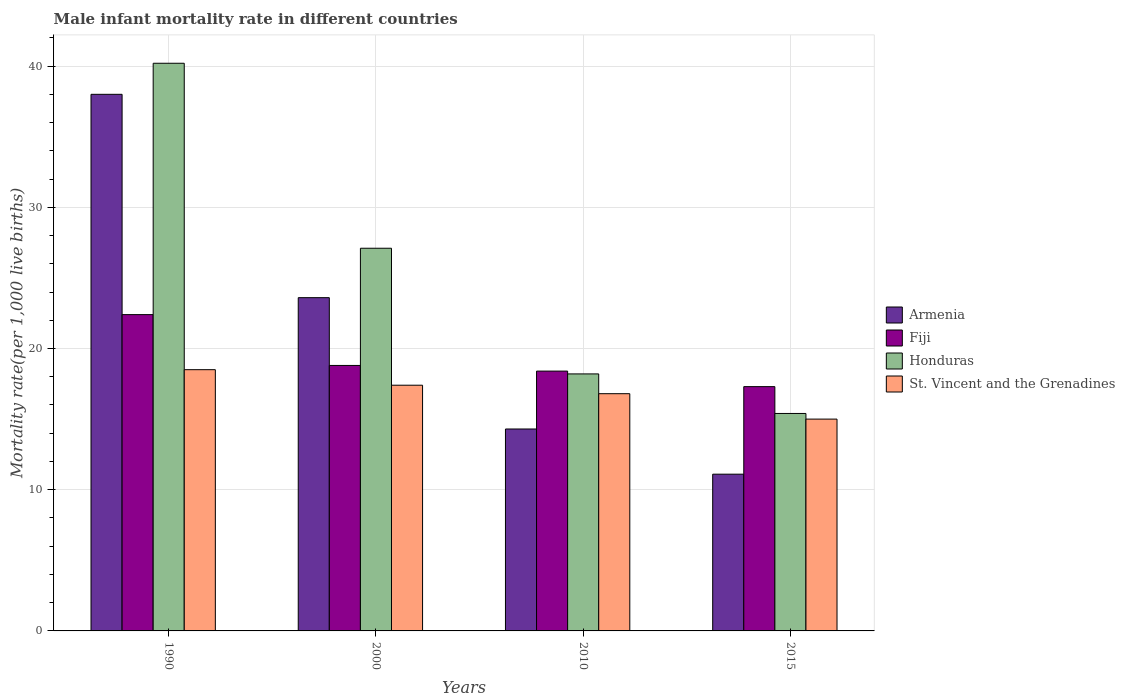Are the number of bars per tick equal to the number of legend labels?
Keep it short and to the point. Yes. How many bars are there on the 3rd tick from the left?
Your response must be concise. 4. What is the label of the 1st group of bars from the left?
Provide a succinct answer. 1990. In how many cases, is the number of bars for a given year not equal to the number of legend labels?
Provide a short and direct response. 0. What is the male infant mortality rate in Armenia in 1990?
Ensure brevity in your answer.  38. Across all years, what is the maximum male infant mortality rate in Honduras?
Your answer should be very brief. 40.2. In which year was the male infant mortality rate in Armenia minimum?
Your answer should be very brief. 2015. What is the total male infant mortality rate in Fiji in the graph?
Your response must be concise. 76.9. What is the difference between the male infant mortality rate in Fiji in 1990 and that in 2000?
Offer a terse response. 3.6. What is the difference between the male infant mortality rate in Fiji in 2015 and the male infant mortality rate in Armenia in 1990?
Provide a short and direct response. -20.7. What is the average male infant mortality rate in St. Vincent and the Grenadines per year?
Your response must be concise. 16.93. In how many years, is the male infant mortality rate in Honduras greater than 26?
Provide a short and direct response. 2. What is the ratio of the male infant mortality rate in St. Vincent and the Grenadines in 1990 to that in 2010?
Your response must be concise. 1.1. Is the male infant mortality rate in Fiji in 1990 less than that in 2015?
Offer a terse response. No. Is the difference between the male infant mortality rate in St. Vincent and the Grenadines in 2000 and 2010 greater than the difference between the male infant mortality rate in Armenia in 2000 and 2010?
Offer a terse response. No. What is the difference between the highest and the second highest male infant mortality rate in Armenia?
Your answer should be very brief. 14.4. What is the difference between the highest and the lowest male infant mortality rate in Honduras?
Offer a terse response. 24.8. In how many years, is the male infant mortality rate in St. Vincent and the Grenadines greater than the average male infant mortality rate in St. Vincent and the Grenadines taken over all years?
Keep it short and to the point. 2. Is the sum of the male infant mortality rate in St. Vincent and the Grenadines in 2010 and 2015 greater than the maximum male infant mortality rate in Honduras across all years?
Give a very brief answer. No. Is it the case that in every year, the sum of the male infant mortality rate in Fiji and male infant mortality rate in St. Vincent and the Grenadines is greater than the sum of male infant mortality rate in Armenia and male infant mortality rate in Honduras?
Offer a terse response. No. What does the 3rd bar from the left in 2010 represents?
Make the answer very short. Honduras. What does the 2nd bar from the right in 2015 represents?
Your response must be concise. Honduras. Are all the bars in the graph horizontal?
Give a very brief answer. No. What is the difference between two consecutive major ticks on the Y-axis?
Your answer should be very brief. 10. Are the values on the major ticks of Y-axis written in scientific E-notation?
Ensure brevity in your answer.  No. Does the graph contain any zero values?
Offer a very short reply. No. How many legend labels are there?
Your response must be concise. 4. What is the title of the graph?
Give a very brief answer. Male infant mortality rate in different countries. Does "Ireland" appear as one of the legend labels in the graph?
Your answer should be very brief. No. What is the label or title of the Y-axis?
Your response must be concise. Mortality rate(per 1,0 live births). What is the Mortality rate(per 1,000 live births) in Armenia in 1990?
Ensure brevity in your answer.  38. What is the Mortality rate(per 1,000 live births) in Fiji in 1990?
Keep it short and to the point. 22.4. What is the Mortality rate(per 1,000 live births) in Honduras in 1990?
Give a very brief answer. 40.2. What is the Mortality rate(per 1,000 live births) of St. Vincent and the Grenadines in 1990?
Your response must be concise. 18.5. What is the Mortality rate(per 1,000 live births) in Armenia in 2000?
Provide a short and direct response. 23.6. What is the Mortality rate(per 1,000 live births) in Fiji in 2000?
Your answer should be compact. 18.8. What is the Mortality rate(per 1,000 live births) in Honduras in 2000?
Make the answer very short. 27.1. What is the Mortality rate(per 1,000 live births) in Armenia in 2010?
Provide a succinct answer. 14.3. What is the Mortality rate(per 1,000 live births) of Honduras in 2015?
Your response must be concise. 15.4. Across all years, what is the maximum Mortality rate(per 1,000 live births) in Armenia?
Keep it short and to the point. 38. Across all years, what is the maximum Mortality rate(per 1,000 live births) in Fiji?
Your answer should be very brief. 22.4. Across all years, what is the maximum Mortality rate(per 1,000 live births) in Honduras?
Keep it short and to the point. 40.2. Across all years, what is the minimum Mortality rate(per 1,000 live births) of Honduras?
Make the answer very short. 15.4. What is the total Mortality rate(per 1,000 live births) of Armenia in the graph?
Make the answer very short. 87. What is the total Mortality rate(per 1,000 live births) in Fiji in the graph?
Keep it short and to the point. 76.9. What is the total Mortality rate(per 1,000 live births) of Honduras in the graph?
Offer a terse response. 100.9. What is the total Mortality rate(per 1,000 live births) in St. Vincent and the Grenadines in the graph?
Provide a succinct answer. 67.7. What is the difference between the Mortality rate(per 1,000 live births) of Armenia in 1990 and that in 2000?
Offer a terse response. 14.4. What is the difference between the Mortality rate(per 1,000 live births) of Fiji in 1990 and that in 2000?
Ensure brevity in your answer.  3.6. What is the difference between the Mortality rate(per 1,000 live births) of St. Vincent and the Grenadines in 1990 and that in 2000?
Keep it short and to the point. 1.1. What is the difference between the Mortality rate(per 1,000 live births) in Armenia in 1990 and that in 2010?
Provide a short and direct response. 23.7. What is the difference between the Mortality rate(per 1,000 live births) in Fiji in 1990 and that in 2010?
Offer a terse response. 4. What is the difference between the Mortality rate(per 1,000 live births) of Armenia in 1990 and that in 2015?
Ensure brevity in your answer.  26.9. What is the difference between the Mortality rate(per 1,000 live births) of Fiji in 1990 and that in 2015?
Your response must be concise. 5.1. What is the difference between the Mortality rate(per 1,000 live births) of Honduras in 1990 and that in 2015?
Make the answer very short. 24.8. What is the difference between the Mortality rate(per 1,000 live births) of St. Vincent and the Grenadines in 1990 and that in 2015?
Your answer should be compact. 3.5. What is the difference between the Mortality rate(per 1,000 live births) in Armenia in 2000 and that in 2010?
Your answer should be very brief. 9.3. What is the difference between the Mortality rate(per 1,000 live births) of Honduras in 2000 and that in 2010?
Give a very brief answer. 8.9. What is the difference between the Mortality rate(per 1,000 live births) in Armenia in 2000 and that in 2015?
Give a very brief answer. 12.5. What is the difference between the Mortality rate(per 1,000 live births) of St. Vincent and the Grenadines in 2000 and that in 2015?
Offer a very short reply. 2.4. What is the difference between the Mortality rate(per 1,000 live births) of Armenia in 1990 and the Mortality rate(per 1,000 live births) of Fiji in 2000?
Offer a very short reply. 19.2. What is the difference between the Mortality rate(per 1,000 live births) of Armenia in 1990 and the Mortality rate(per 1,000 live births) of Honduras in 2000?
Offer a terse response. 10.9. What is the difference between the Mortality rate(per 1,000 live births) in Armenia in 1990 and the Mortality rate(per 1,000 live births) in St. Vincent and the Grenadines in 2000?
Offer a terse response. 20.6. What is the difference between the Mortality rate(per 1,000 live births) in Honduras in 1990 and the Mortality rate(per 1,000 live births) in St. Vincent and the Grenadines in 2000?
Your answer should be compact. 22.8. What is the difference between the Mortality rate(per 1,000 live births) of Armenia in 1990 and the Mortality rate(per 1,000 live births) of Fiji in 2010?
Make the answer very short. 19.6. What is the difference between the Mortality rate(per 1,000 live births) in Armenia in 1990 and the Mortality rate(per 1,000 live births) in Honduras in 2010?
Your response must be concise. 19.8. What is the difference between the Mortality rate(per 1,000 live births) of Armenia in 1990 and the Mortality rate(per 1,000 live births) of St. Vincent and the Grenadines in 2010?
Offer a terse response. 21.2. What is the difference between the Mortality rate(per 1,000 live births) of Honduras in 1990 and the Mortality rate(per 1,000 live births) of St. Vincent and the Grenadines in 2010?
Your answer should be very brief. 23.4. What is the difference between the Mortality rate(per 1,000 live births) in Armenia in 1990 and the Mortality rate(per 1,000 live births) in Fiji in 2015?
Your answer should be compact. 20.7. What is the difference between the Mortality rate(per 1,000 live births) of Armenia in 1990 and the Mortality rate(per 1,000 live births) of Honduras in 2015?
Offer a terse response. 22.6. What is the difference between the Mortality rate(per 1,000 live births) of Armenia in 1990 and the Mortality rate(per 1,000 live births) of St. Vincent and the Grenadines in 2015?
Your answer should be compact. 23. What is the difference between the Mortality rate(per 1,000 live births) of Fiji in 1990 and the Mortality rate(per 1,000 live births) of Honduras in 2015?
Make the answer very short. 7. What is the difference between the Mortality rate(per 1,000 live births) of Fiji in 1990 and the Mortality rate(per 1,000 live births) of St. Vincent and the Grenadines in 2015?
Provide a succinct answer. 7.4. What is the difference between the Mortality rate(per 1,000 live births) in Honduras in 1990 and the Mortality rate(per 1,000 live births) in St. Vincent and the Grenadines in 2015?
Give a very brief answer. 25.2. What is the difference between the Mortality rate(per 1,000 live births) in Fiji in 2000 and the Mortality rate(per 1,000 live births) in Honduras in 2010?
Provide a short and direct response. 0.6. What is the difference between the Mortality rate(per 1,000 live births) in Fiji in 2000 and the Mortality rate(per 1,000 live births) in St. Vincent and the Grenadines in 2010?
Offer a very short reply. 2. What is the difference between the Mortality rate(per 1,000 live births) of Armenia in 2000 and the Mortality rate(per 1,000 live births) of Fiji in 2015?
Your response must be concise. 6.3. What is the difference between the Mortality rate(per 1,000 live births) of Armenia in 2000 and the Mortality rate(per 1,000 live births) of St. Vincent and the Grenadines in 2015?
Offer a very short reply. 8.6. What is the difference between the Mortality rate(per 1,000 live births) of Fiji in 2000 and the Mortality rate(per 1,000 live births) of Honduras in 2015?
Offer a terse response. 3.4. What is the difference between the Mortality rate(per 1,000 live births) of Fiji in 2000 and the Mortality rate(per 1,000 live births) of St. Vincent and the Grenadines in 2015?
Give a very brief answer. 3.8. What is the difference between the Mortality rate(per 1,000 live births) in Armenia in 2010 and the Mortality rate(per 1,000 live births) in St. Vincent and the Grenadines in 2015?
Provide a short and direct response. -0.7. What is the difference between the Mortality rate(per 1,000 live births) in Fiji in 2010 and the Mortality rate(per 1,000 live births) in Honduras in 2015?
Make the answer very short. 3. What is the difference between the Mortality rate(per 1,000 live births) of Honduras in 2010 and the Mortality rate(per 1,000 live births) of St. Vincent and the Grenadines in 2015?
Provide a short and direct response. 3.2. What is the average Mortality rate(per 1,000 live births) of Armenia per year?
Provide a succinct answer. 21.75. What is the average Mortality rate(per 1,000 live births) of Fiji per year?
Provide a short and direct response. 19.23. What is the average Mortality rate(per 1,000 live births) in Honduras per year?
Ensure brevity in your answer.  25.23. What is the average Mortality rate(per 1,000 live births) of St. Vincent and the Grenadines per year?
Make the answer very short. 16.93. In the year 1990, what is the difference between the Mortality rate(per 1,000 live births) in Armenia and Mortality rate(per 1,000 live births) in Fiji?
Provide a short and direct response. 15.6. In the year 1990, what is the difference between the Mortality rate(per 1,000 live births) in Armenia and Mortality rate(per 1,000 live births) in Honduras?
Make the answer very short. -2.2. In the year 1990, what is the difference between the Mortality rate(per 1,000 live births) in Fiji and Mortality rate(per 1,000 live births) in Honduras?
Ensure brevity in your answer.  -17.8. In the year 1990, what is the difference between the Mortality rate(per 1,000 live births) of Honduras and Mortality rate(per 1,000 live births) of St. Vincent and the Grenadines?
Provide a succinct answer. 21.7. In the year 2000, what is the difference between the Mortality rate(per 1,000 live births) in Fiji and Mortality rate(per 1,000 live births) in Honduras?
Offer a terse response. -8.3. In the year 2000, what is the difference between the Mortality rate(per 1,000 live births) of Honduras and Mortality rate(per 1,000 live births) of St. Vincent and the Grenadines?
Offer a very short reply. 9.7. In the year 2010, what is the difference between the Mortality rate(per 1,000 live births) of Fiji and Mortality rate(per 1,000 live births) of Honduras?
Keep it short and to the point. 0.2. In the year 2010, what is the difference between the Mortality rate(per 1,000 live births) in Honduras and Mortality rate(per 1,000 live births) in St. Vincent and the Grenadines?
Ensure brevity in your answer.  1.4. In the year 2015, what is the difference between the Mortality rate(per 1,000 live births) in Armenia and Mortality rate(per 1,000 live births) in Fiji?
Offer a very short reply. -6.2. In the year 2015, what is the difference between the Mortality rate(per 1,000 live births) of Fiji and Mortality rate(per 1,000 live births) of Honduras?
Make the answer very short. 1.9. In the year 2015, what is the difference between the Mortality rate(per 1,000 live births) in Fiji and Mortality rate(per 1,000 live births) in St. Vincent and the Grenadines?
Give a very brief answer. 2.3. In the year 2015, what is the difference between the Mortality rate(per 1,000 live births) in Honduras and Mortality rate(per 1,000 live births) in St. Vincent and the Grenadines?
Make the answer very short. 0.4. What is the ratio of the Mortality rate(per 1,000 live births) of Armenia in 1990 to that in 2000?
Your answer should be compact. 1.61. What is the ratio of the Mortality rate(per 1,000 live births) of Fiji in 1990 to that in 2000?
Your answer should be very brief. 1.19. What is the ratio of the Mortality rate(per 1,000 live births) of Honduras in 1990 to that in 2000?
Keep it short and to the point. 1.48. What is the ratio of the Mortality rate(per 1,000 live births) in St. Vincent and the Grenadines in 1990 to that in 2000?
Make the answer very short. 1.06. What is the ratio of the Mortality rate(per 1,000 live births) in Armenia in 1990 to that in 2010?
Make the answer very short. 2.66. What is the ratio of the Mortality rate(per 1,000 live births) in Fiji in 1990 to that in 2010?
Provide a succinct answer. 1.22. What is the ratio of the Mortality rate(per 1,000 live births) in Honduras in 1990 to that in 2010?
Keep it short and to the point. 2.21. What is the ratio of the Mortality rate(per 1,000 live births) in St. Vincent and the Grenadines in 1990 to that in 2010?
Keep it short and to the point. 1.1. What is the ratio of the Mortality rate(per 1,000 live births) of Armenia in 1990 to that in 2015?
Make the answer very short. 3.42. What is the ratio of the Mortality rate(per 1,000 live births) of Fiji in 1990 to that in 2015?
Provide a short and direct response. 1.29. What is the ratio of the Mortality rate(per 1,000 live births) of Honduras in 1990 to that in 2015?
Your answer should be compact. 2.61. What is the ratio of the Mortality rate(per 1,000 live births) in St. Vincent and the Grenadines in 1990 to that in 2015?
Make the answer very short. 1.23. What is the ratio of the Mortality rate(per 1,000 live births) in Armenia in 2000 to that in 2010?
Provide a short and direct response. 1.65. What is the ratio of the Mortality rate(per 1,000 live births) of Fiji in 2000 to that in 2010?
Provide a succinct answer. 1.02. What is the ratio of the Mortality rate(per 1,000 live births) of Honduras in 2000 to that in 2010?
Offer a terse response. 1.49. What is the ratio of the Mortality rate(per 1,000 live births) of St. Vincent and the Grenadines in 2000 to that in 2010?
Provide a short and direct response. 1.04. What is the ratio of the Mortality rate(per 1,000 live births) of Armenia in 2000 to that in 2015?
Give a very brief answer. 2.13. What is the ratio of the Mortality rate(per 1,000 live births) in Fiji in 2000 to that in 2015?
Ensure brevity in your answer.  1.09. What is the ratio of the Mortality rate(per 1,000 live births) in Honduras in 2000 to that in 2015?
Your answer should be very brief. 1.76. What is the ratio of the Mortality rate(per 1,000 live births) of St. Vincent and the Grenadines in 2000 to that in 2015?
Give a very brief answer. 1.16. What is the ratio of the Mortality rate(per 1,000 live births) of Armenia in 2010 to that in 2015?
Provide a short and direct response. 1.29. What is the ratio of the Mortality rate(per 1,000 live births) of Fiji in 2010 to that in 2015?
Make the answer very short. 1.06. What is the ratio of the Mortality rate(per 1,000 live births) of Honduras in 2010 to that in 2015?
Provide a short and direct response. 1.18. What is the ratio of the Mortality rate(per 1,000 live births) in St. Vincent and the Grenadines in 2010 to that in 2015?
Give a very brief answer. 1.12. What is the difference between the highest and the second highest Mortality rate(per 1,000 live births) of Fiji?
Provide a succinct answer. 3.6. What is the difference between the highest and the lowest Mortality rate(per 1,000 live births) of Armenia?
Provide a succinct answer. 26.9. What is the difference between the highest and the lowest Mortality rate(per 1,000 live births) in Honduras?
Make the answer very short. 24.8. What is the difference between the highest and the lowest Mortality rate(per 1,000 live births) in St. Vincent and the Grenadines?
Offer a terse response. 3.5. 